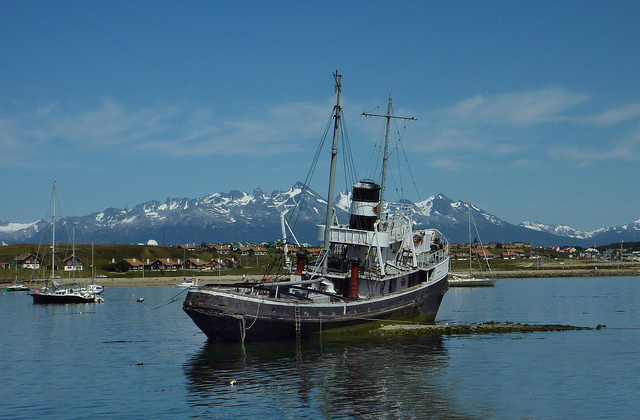<image>What is posted at the front of the boat? It is unclear what is posted at the front of the boat. It could be an anchor, rope, net, mast, or guardrail. What is posted at the front of the boat? I don't know what is posted at the front of the boat. It can be seen 'anchor', 'rope', 'steering wheel', 'lines', 'net', 'mast', or 'guardrail'. 